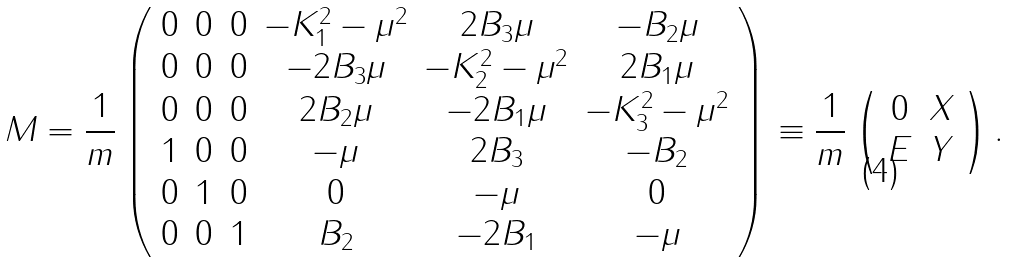Convert formula to latex. <formula><loc_0><loc_0><loc_500><loc_500>M = \frac { 1 } { m } \left ( \begin{array} { c c c c c c } 0 & 0 & 0 & - K _ { 1 } ^ { 2 } - \mu ^ { 2 } & 2 B _ { 3 } \mu & - B _ { 2 } \mu \\ 0 & 0 & 0 & - 2 B _ { 3 } \mu & - K _ { 2 } ^ { 2 } - \mu ^ { 2 } & 2 B _ { 1 } \mu \\ 0 & 0 & 0 & 2 B _ { 2 } \mu & - 2 B _ { 1 } \mu & - K _ { 3 } ^ { 2 } - \mu ^ { 2 } \\ 1 & 0 & 0 & - \mu & 2 B _ { 3 } & - B _ { 2 } \\ 0 & 1 & 0 & 0 & - \mu & 0 \\ 0 & 0 & 1 & B _ { 2 } & - 2 B _ { 1 } & - \mu \end{array} \right ) \equiv \frac { 1 } { m } \left ( \begin{array} { c c } 0 & X \\ E & Y \end{array} \right ) .</formula> 